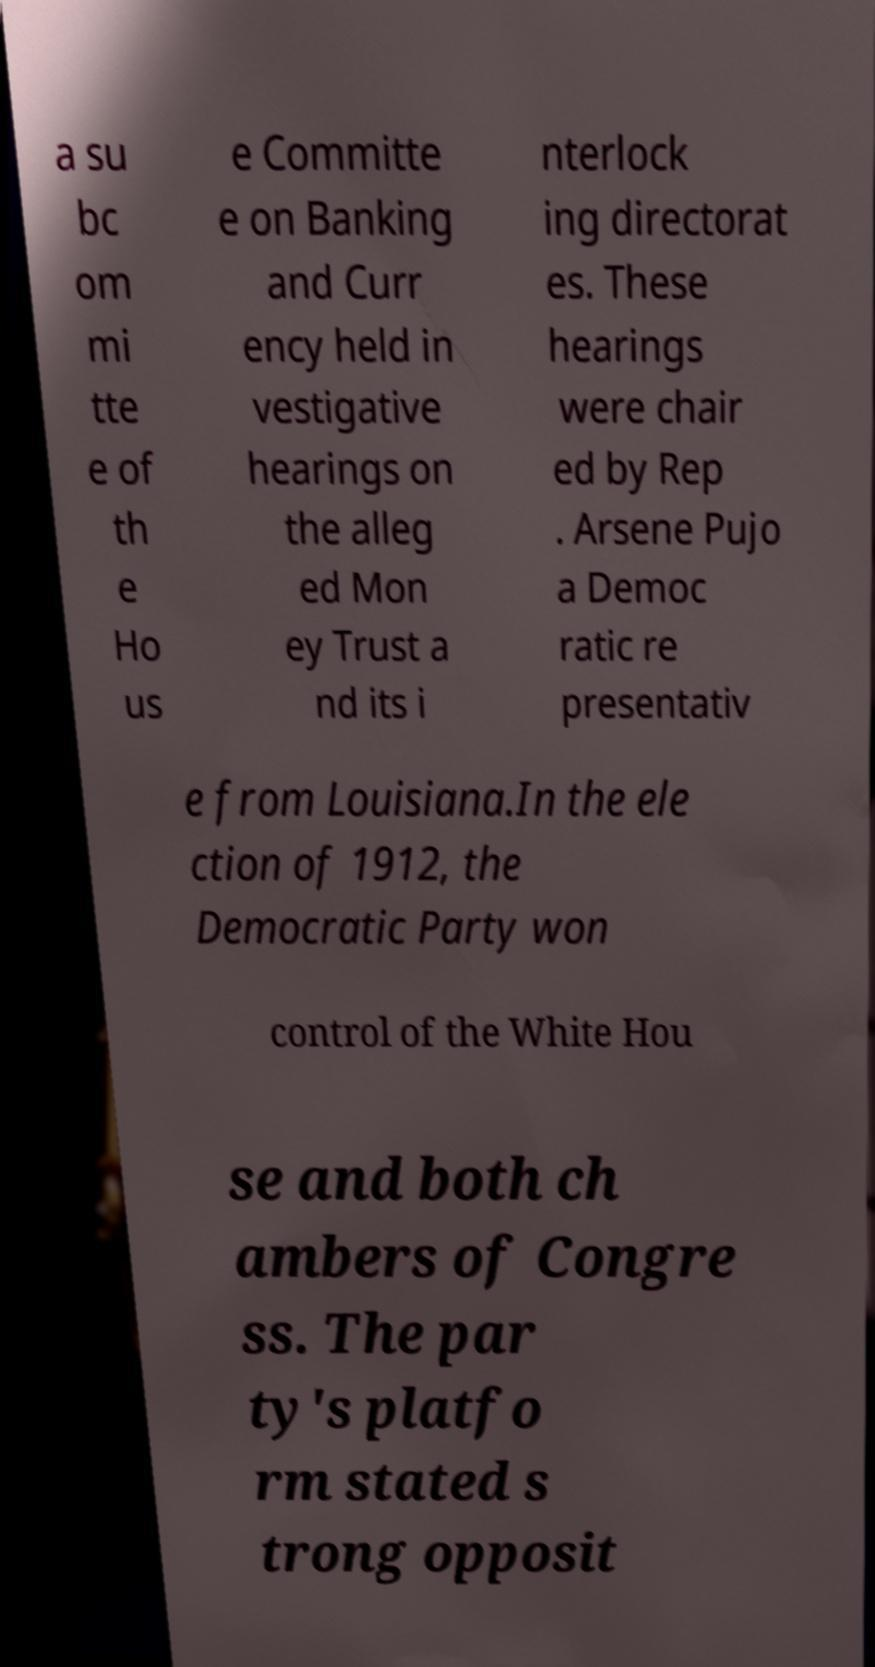What messages or text are displayed in this image? I need them in a readable, typed format. a su bc om mi tte e of th e Ho us e Committe e on Banking and Curr ency held in vestigative hearings on the alleg ed Mon ey Trust a nd its i nterlock ing directorat es. These hearings were chair ed by Rep . Arsene Pujo a Democ ratic re presentativ e from Louisiana.In the ele ction of 1912, the Democratic Party won control of the White Hou se and both ch ambers of Congre ss. The par ty's platfo rm stated s trong opposit 